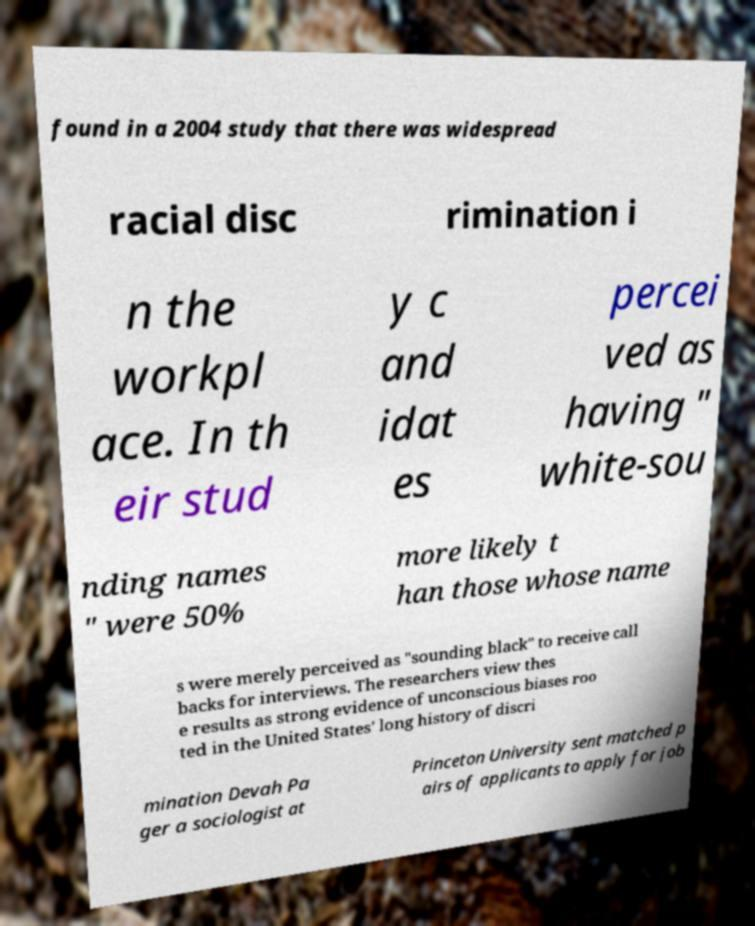Could you assist in decoding the text presented in this image and type it out clearly? found in a 2004 study that there was widespread racial disc rimination i n the workpl ace. In th eir stud y c and idat es percei ved as having " white-sou nding names " were 50% more likely t han those whose name s were merely perceived as "sounding black" to receive call backs for interviews. The researchers view thes e results as strong evidence of unconscious biases roo ted in the United States' long history of discri mination Devah Pa ger a sociologist at Princeton University sent matched p airs of applicants to apply for job 